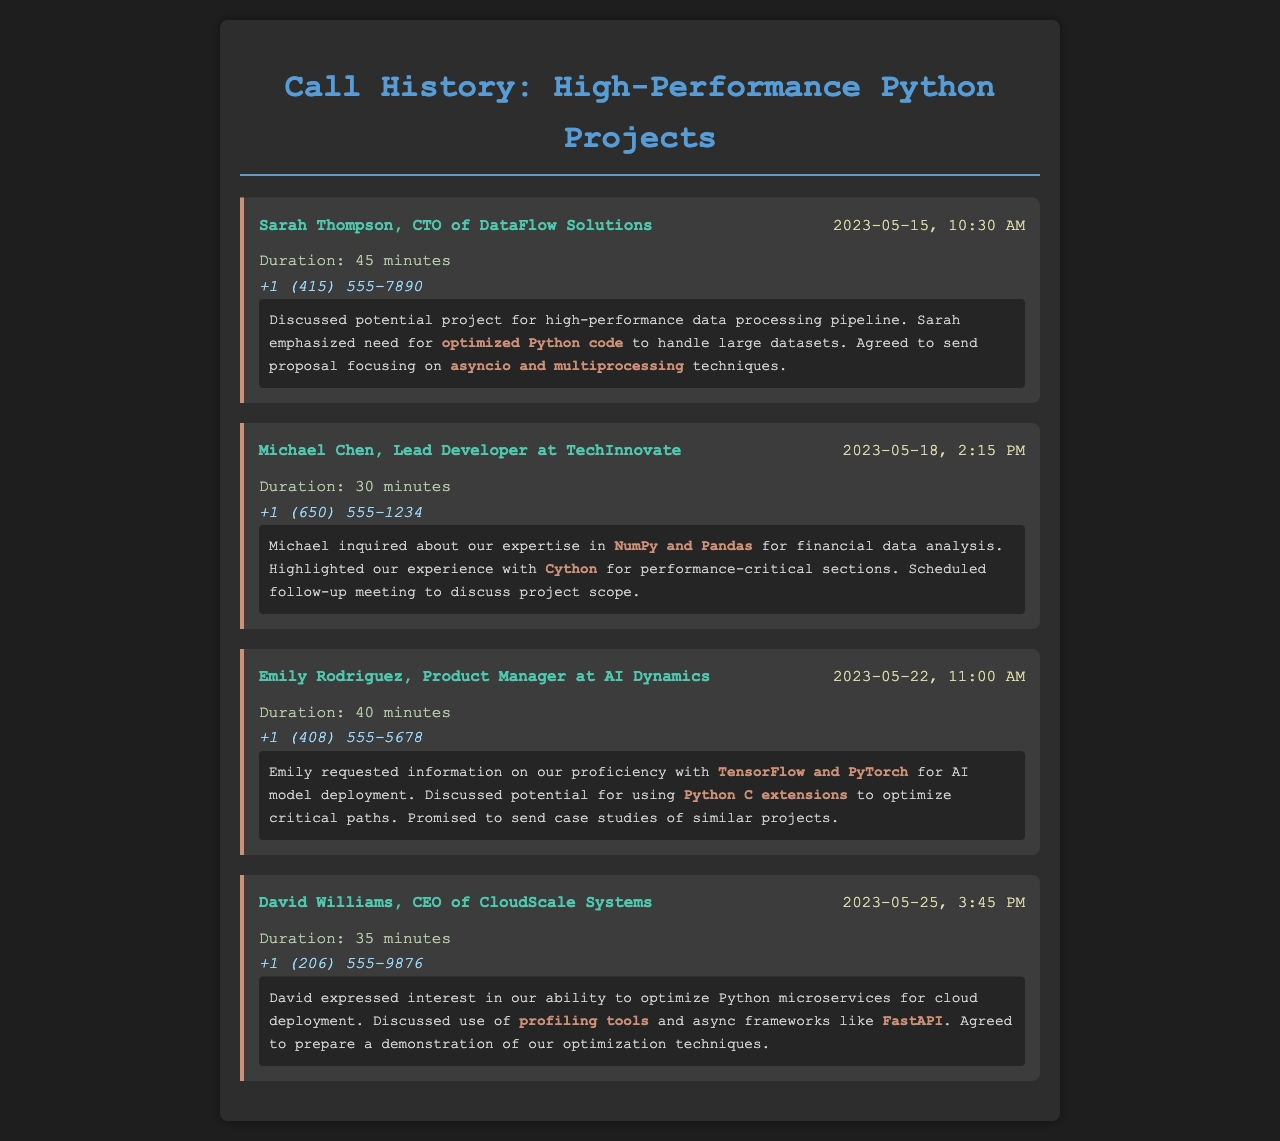What is the name of the contact for the first call? The first call is with Sarah Thompson, as indicated in the document.
Answer: Sarah Thompson What was the duration of the second call? The duration of the second call is explicitly mentioned in the document as 30 minutes.
Answer: 30 minutes When did the call with Emily Rodriguez take place? The date and time of Emily Rodriguez's call is listed as 2023-05-22, 11:00 AM.
Answer: 2023-05-22, 11:00 AM Which technology was discussed in relation to optimizing critical paths? The document notes that Python C extensions were discussed for optimizing critical paths.
Answer: Python C extensions What was the main focus of the conversation with David Williams? The document states that the conversation focused on optimizing Python microservices for cloud deployment.
Answer: Optimizing Python microservices for cloud deployment What follow-up action was scheduled after the call with Michael Chen? The follow-up action scheduled is to discuss the project scope in a subsequent meeting.
Answer: Discuss project scope How many calls are recorded in this document? The document lists a total of four call records, which can be counted.
Answer: Four Which framework was mentioned in connection with async programming during David Williams's call? FastAPI was specifically mentioned as an async framework in the notes of David Williams's call.
Answer: FastAPI What type of analysis was Michael Chen interested in? Michael Chen inquired about expertise in financial data analysis, as noted in the conversation.
Answer: Financial data analysis 